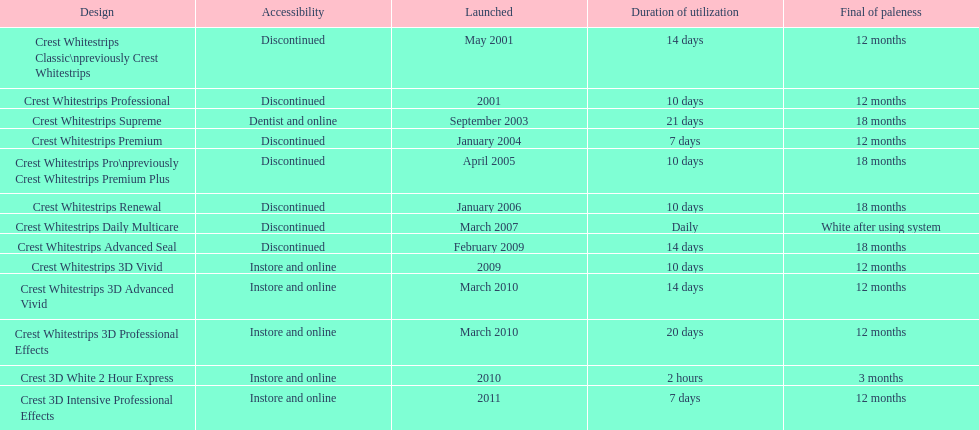Which discontinued product was introduced the same year as crest whitestrips 3d vivid? Crest Whitestrips Advanced Seal. 